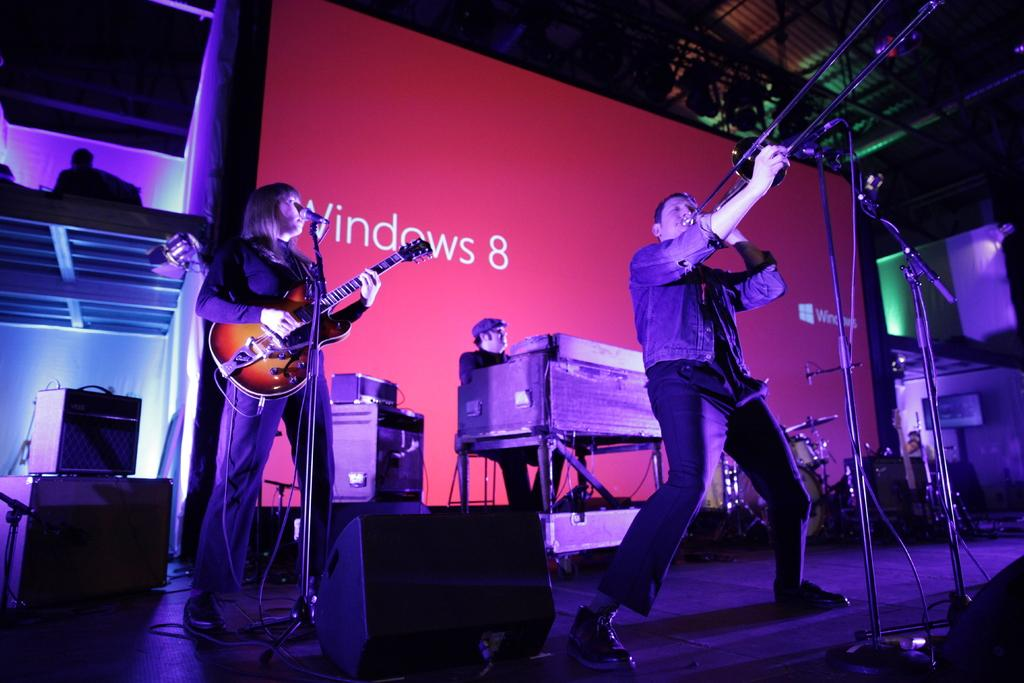What is happening in the image involving the people? There are people on stage in the image, which suggests they might be performing or giving a presentation. What musical instrument can be seen in the image? There is a guitar in the image. What device is present for amplifying sound? There is a microphone in the image. What other musical instruments are visible in the image? There are musical instruments in the image, but the specific instruments are not mentioned in the provided facts. What can be seen on the wall in the image? There is a poster visible in the image. What nation is the governor representing in the image? There is no governor or nation mentioned in the image; it features people on stage, a guitar, a microphone, musical instruments, and a poster. What type of light is being used to illuminate the stage in the image? The provided facts do not mention any lighting or illumination in the image. 